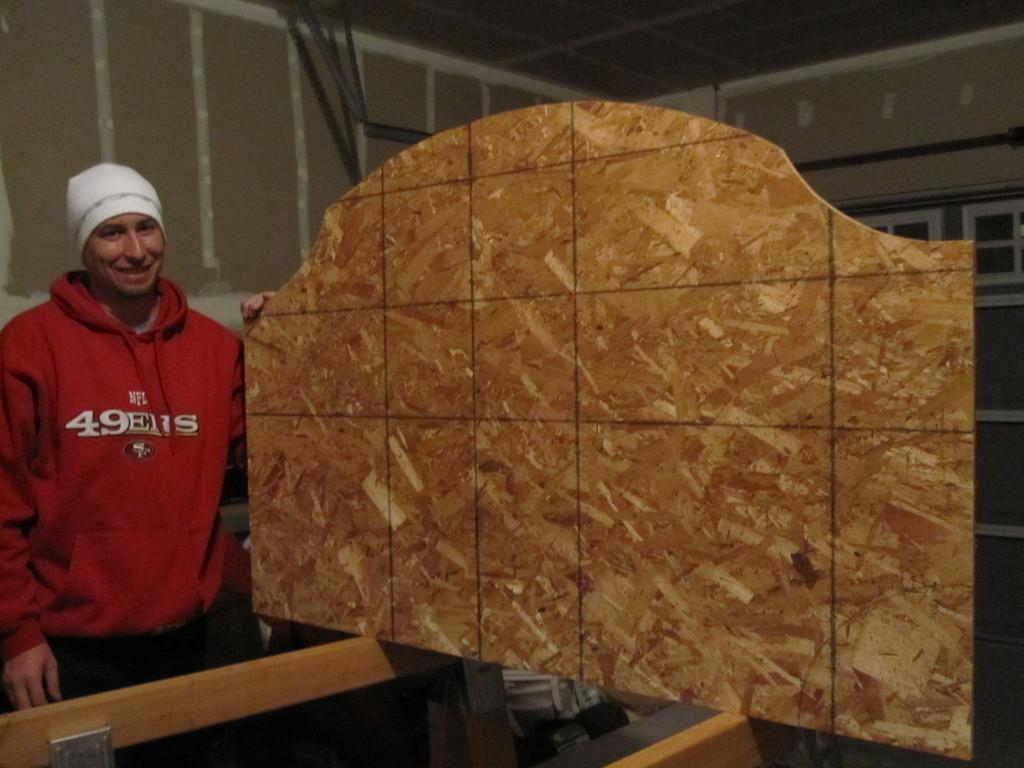Who is present in the image? There is a person in the image. What is the person wearing? The person is wearing a red T-shirt. What is the person holding in the image? The person is holding a wooden structure. What can be seen in the background of the image? There is a wall in the background of the image. What type of jewel is the person wearing around their neck in the image? There is no jewel visible around the person's neck in the image. Who owns the property in the background of the image? The facts provided do not give any information about the ownership of the property in the background. 